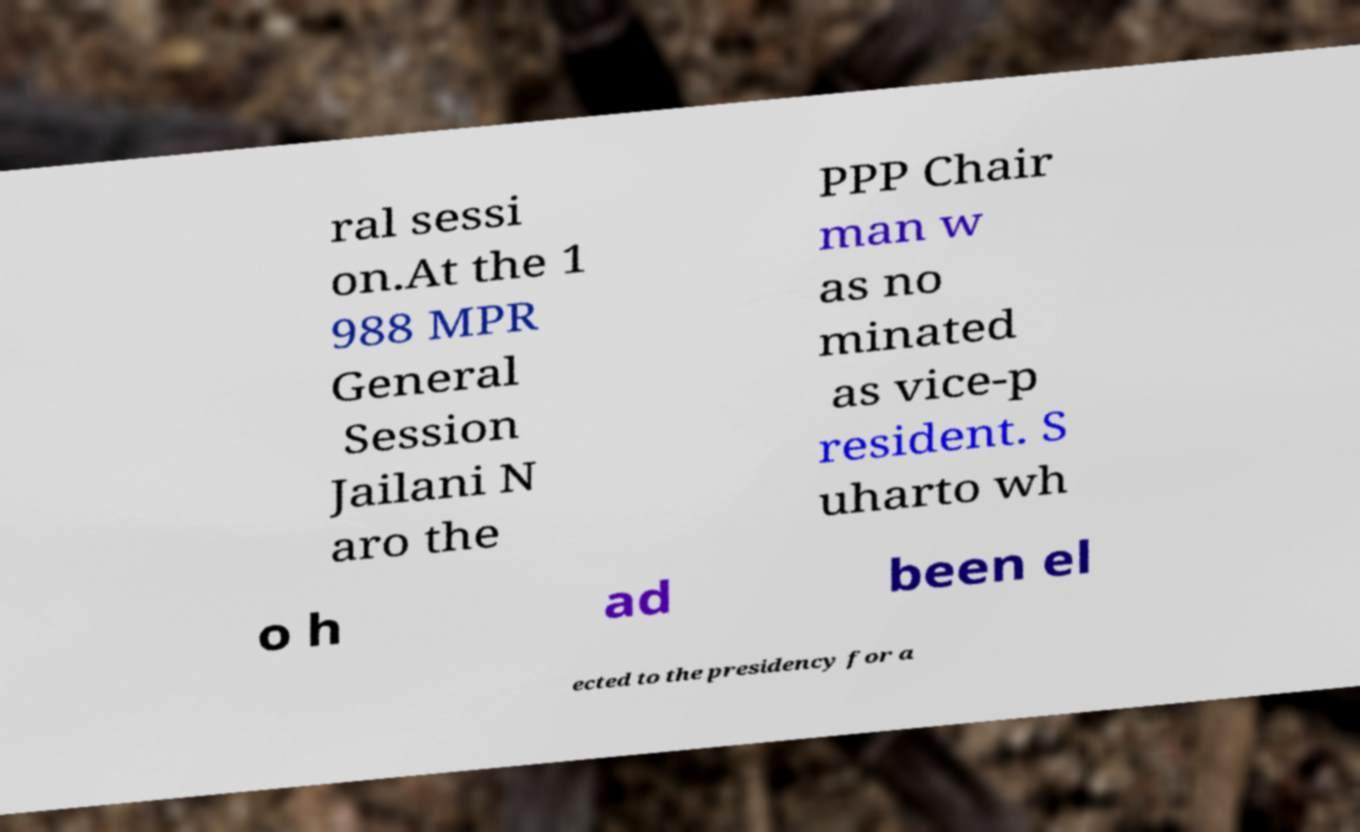Please read and relay the text visible in this image. What does it say? ral sessi on.At the 1 988 MPR General Session Jailani N aro the PPP Chair man w as no minated as vice-p resident. S uharto wh o h ad been el ected to the presidency for a 